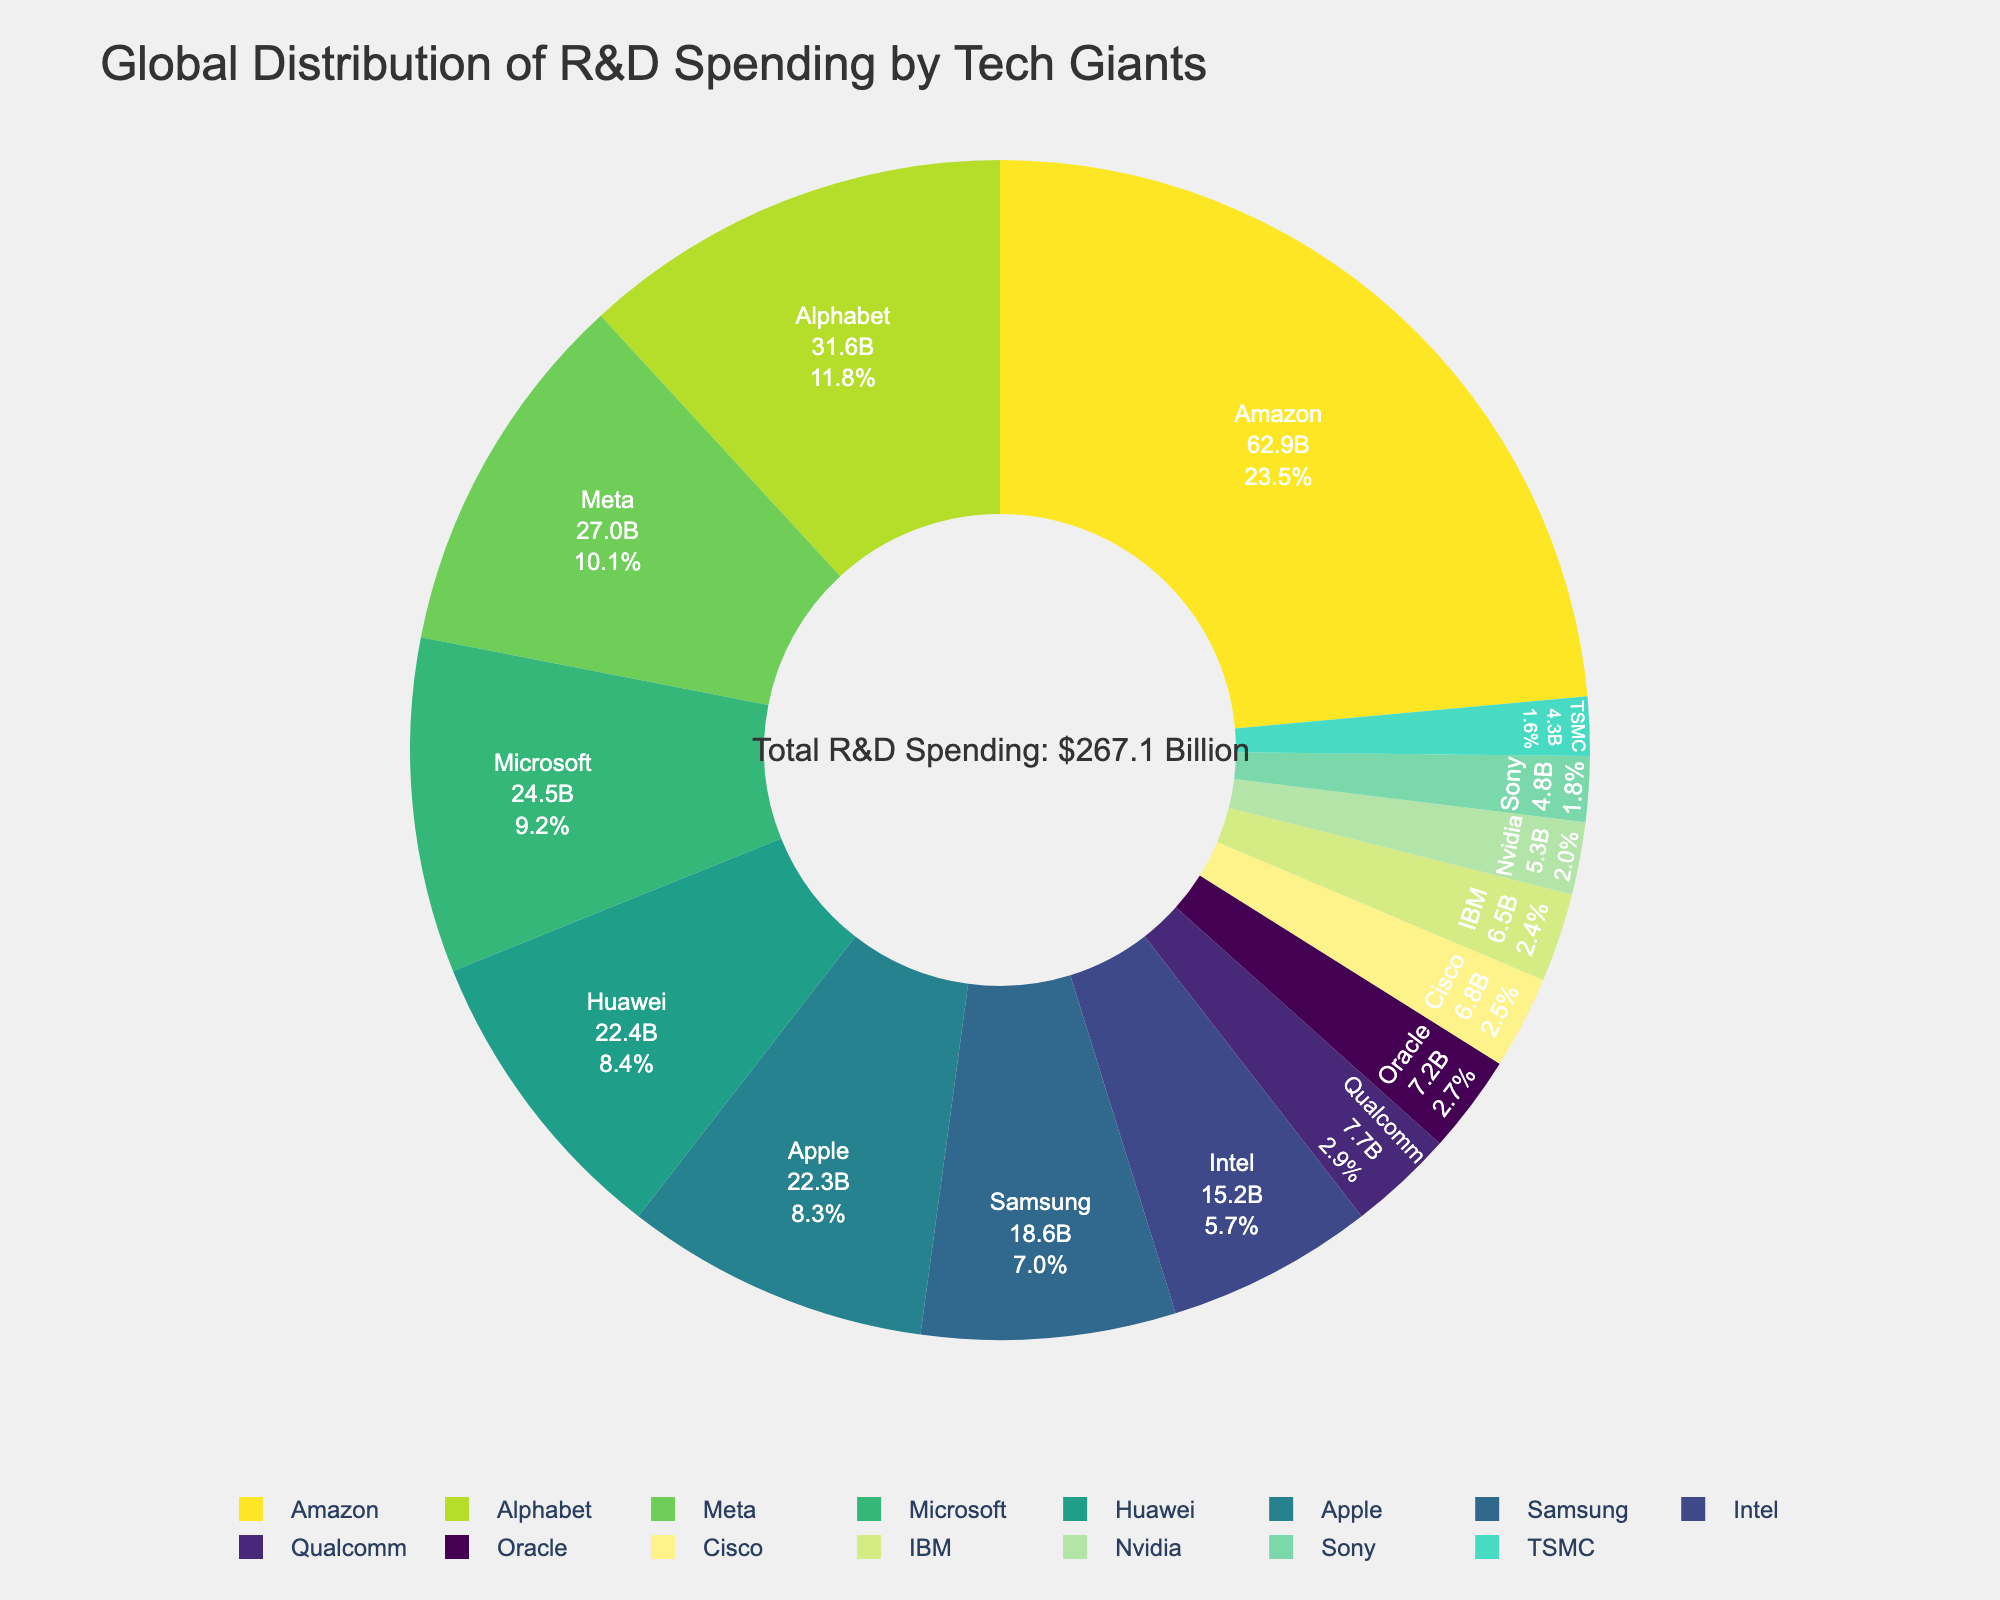What percentage of the total R&D spending does Amazon contribute? Amazon's spending is $62.9 billion. Total R&D spending is sum of all companies, $31.6 + $62.9 + $24.5 + $22.3 + $27.0 + $18.6 + $15.2 + $22.4 + $6.5 + $4.8 + $4.3 + $7.2 + $6.8 + $5.3 + $7.7 = $267.1 billion. Percentage contribution = (62.9 / 267.1) * 100 ≈ 23.5%
Answer: 23.5% Which company spends the least on R&D? Looking at the lowest value in the data, Sony spends $4.3 billion, making it the least.
Answer: Sony How much more does Amazon spend compared to Meta? Amazon spends $62.9 billion and Meta spends $27.0 billion. Difference = $62.9 billion - $27.0 billion = $35.9 billion
Answer: $35.9 billion What is the combined R&D spending of Microsoft and Apple? Microsoft's spending is $24.5 billion, and Apple's spending is $22.3 billion. Combined spending = $24.5 billion + $22.3 billion = $46.8 billion
Answer: $46.8 billion What percentage of the total R&D spending is accounted for by the top 3 companies? Top 3 companies: Amazon ($62.9 billion), Alphabet ($31.6 billion), Meta ($27.0 billion). Combined top 3 spending = $62.9 + $31.6 + $27.0 = $121.5 billion. Percentage = (121.5 / 267.1) * 100 ≈ 45.5%
Answer: 45.5% Is Apple’s R&D spending greater than Samsung’s? Apple's R&D spending is $22.3 billion and Samsung's R&D spending is $18.6 billion. $22.3 billion is greater than $18.6 billion.
Answer: Yes What color is used to represent IBM in the pie chart? Since colors are distributed sequentially, you can identify IBM's position and match it to the corresponding color. IBM comes after Huawei, which might use a lighter shade in the sequence.
Answer: (Assuming one of the Viridis shades from this sequence without exact coding: light green) Which company has nearly similar R&D spending to Qualcomm? Qualcomm's spending is $7.7 billion, very close to Oracle's R&D spending of $7.2 billion.
Answer: Oracle How many companies have R&D spending greater than $20 billion? The companies with R&D spending greater than $20 billion are Amazon ($62.9 billion), Alphabet ($31.6 billion), Meta ($27.0 billion), Microsoft ($24.5 billion), Apple ($22.3 billion), and Huawei ($22.4 billion).
Answer: 6 